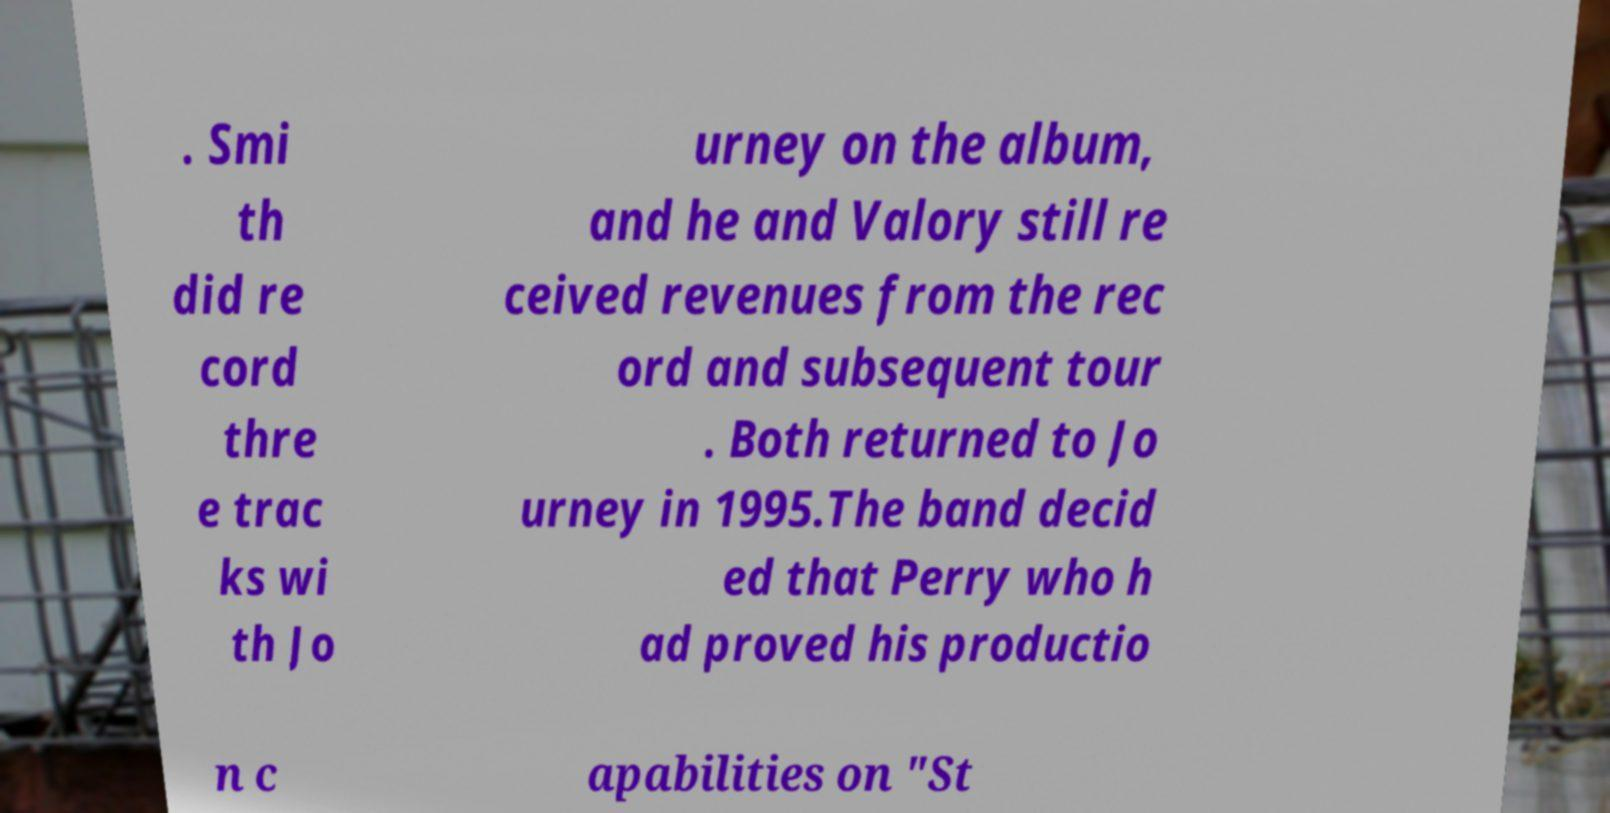Please read and relay the text visible in this image. What does it say? . Smi th did re cord thre e trac ks wi th Jo urney on the album, and he and Valory still re ceived revenues from the rec ord and subsequent tour . Both returned to Jo urney in 1995.The band decid ed that Perry who h ad proved his productio n c apabilities on "St 